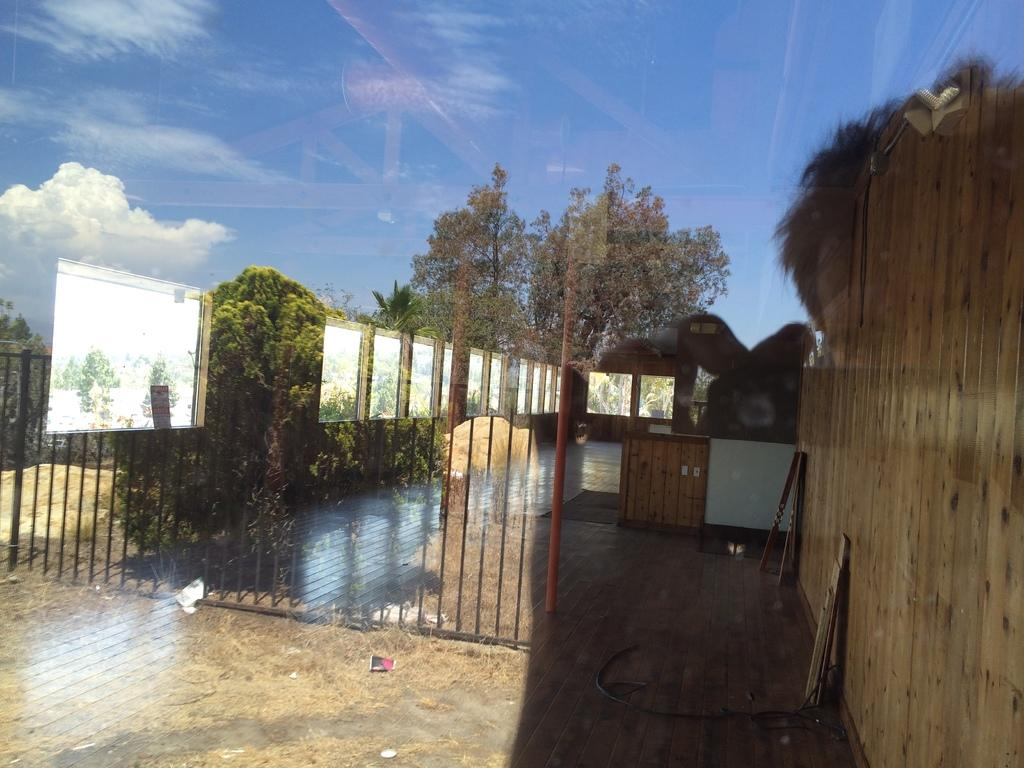What can be seen on the grass in the image? There is a reflection on the grass in the image. What elements are included in the reflection? The reflection includes trees, huts, and screens. What is visible in the sky in the image? There are clouds in the sky. What type of rhythm can be heard coming from the huts in the image? There is no sound or rhythm present in the image, as it is a still reflection of huts, trees, and screens on the grass. 